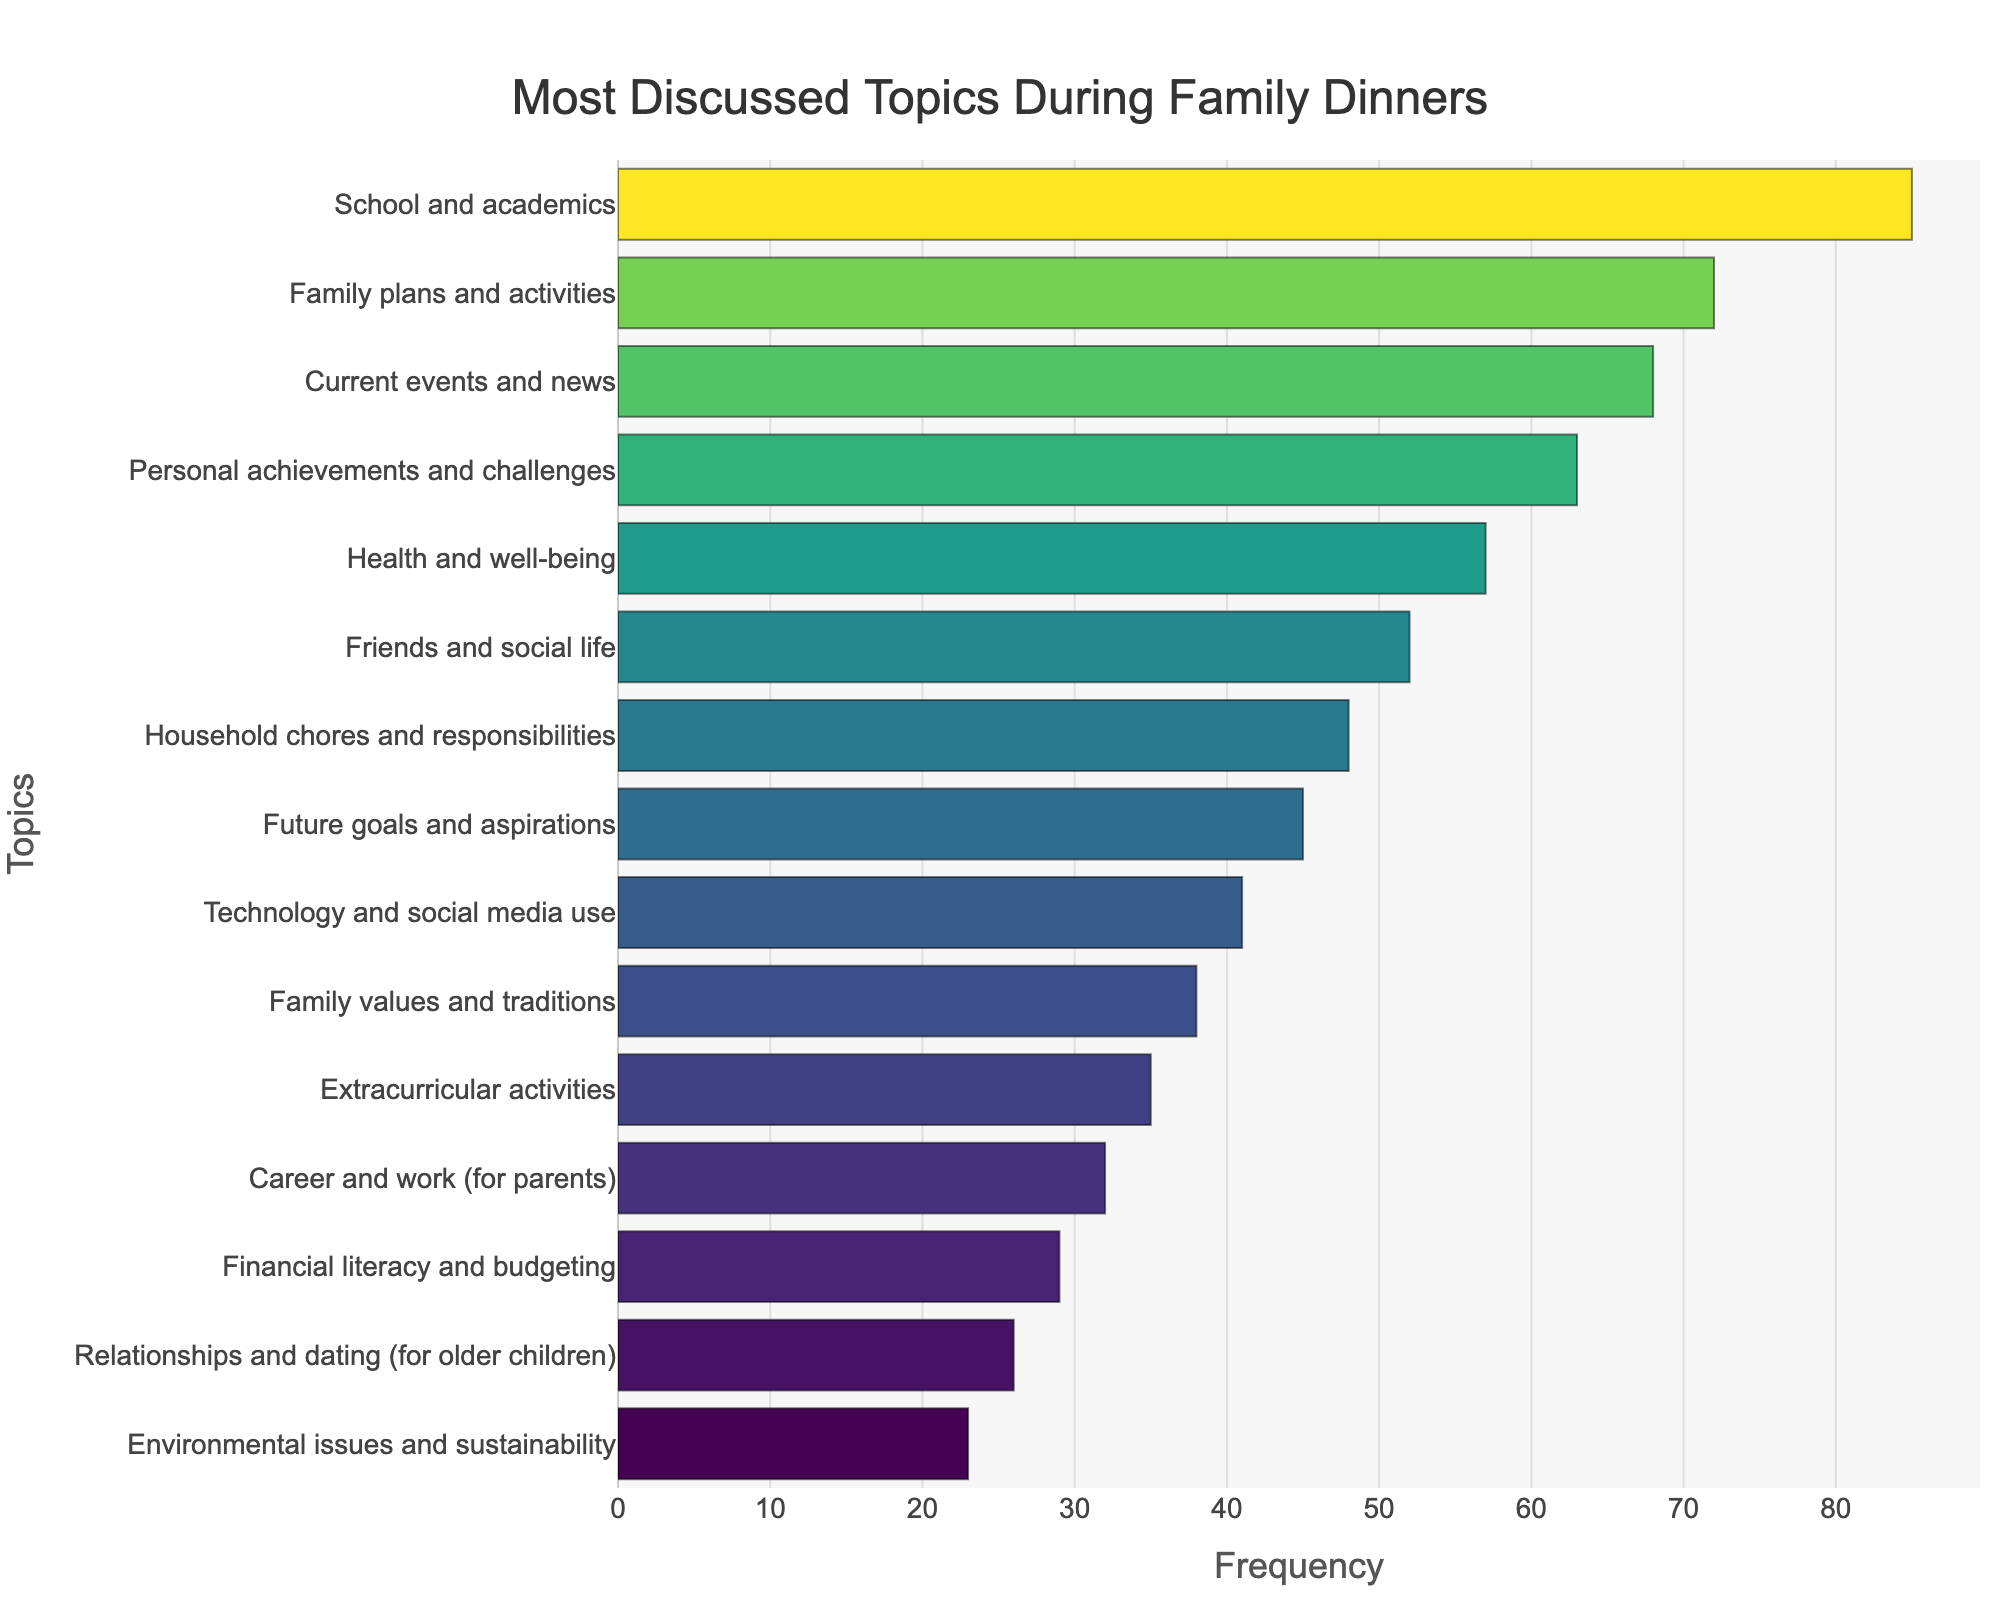What is the most frequently discussed topic during family dinners? The bar chart shows the topics discussed during family dinners, with "School and academics" having the longest bar.
Answer: School and academics Which topic has a lower frequency of discussion: "Career and work (for parents)" or "Friends and social life"? Referring to the lengths of the bars, "Career and work (for parents)" has a shorter bar than "Friends and social life."
Answer: Career and work (for parents) What is the combined frequency of discussions on "Technology and social media use" and "Family values and traditions"? Adding the frequencies from the chart: "Technology and social media use" (41) + "Family values and traditions" (38) = 79.
Answer: 79 By how much does the frequency of "Personal achievements and challenges" surpass that of "Environmental issues and sustainability"? Subtracting the frequency of "Environmental issues and sustainability" (23) from "Personal achievements and challenges" (63): 63 - 23 = 40.
Answer: 40 Which topic has a similar frequency to "Family plans and activities"? "Current events and news" has a frequency (68) close to that of "Family plans and activities" (72).
Answer: Current events and news Arrange the topics "Household chores and responsibilities," "Future goals and aspirations," and "Extracurricular activities" in ascending order of their frequency. According to the bar lengths: "Extracurricular activities" (35), "Future goals and aspirations" (45), "Household chores and responsibilities" (48).
Answer: Extracurricular activities, Future goals and aspirations, Household chores and responsibilities What is the difference in the frequency of discussions between the most discussed topic and the least discussed topic? "School and academics" is 85 (most discussed), and "Environmental issues and sustainability" is 23 (least discussed). The difference is 85 - 23 = 62.
Answer: 62 How many topics have a discussion frequency greater than 50? Counting the topics with bars longer than 50 on the frequency scale: 6 topics ("School and academics," "Family plans and activities," "Current events and news," "Personal achievements and challenges," "Health and well-being," and "Friends and social life").
Answer: 6 